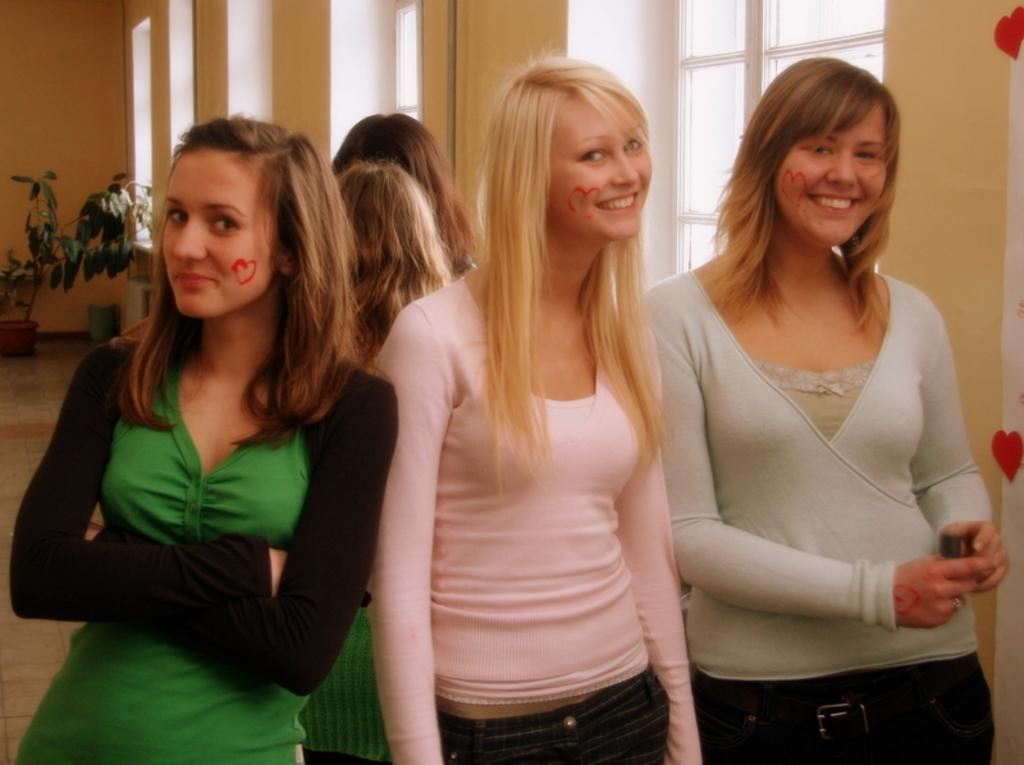What is happening in the middle of the image? There are women standing in the middle of the image. What is the facial expression of the women? The women are smiling. What can be seen in the background of the image? There is a wall and plants in the background of the image. What architectural feature is present on the wall? There are windows on the wall. What type of song is being sung by the stone in the image? There is no stone or singing present in the image; it features women standing and smiling in front of a wall with windows and plants in the background. 